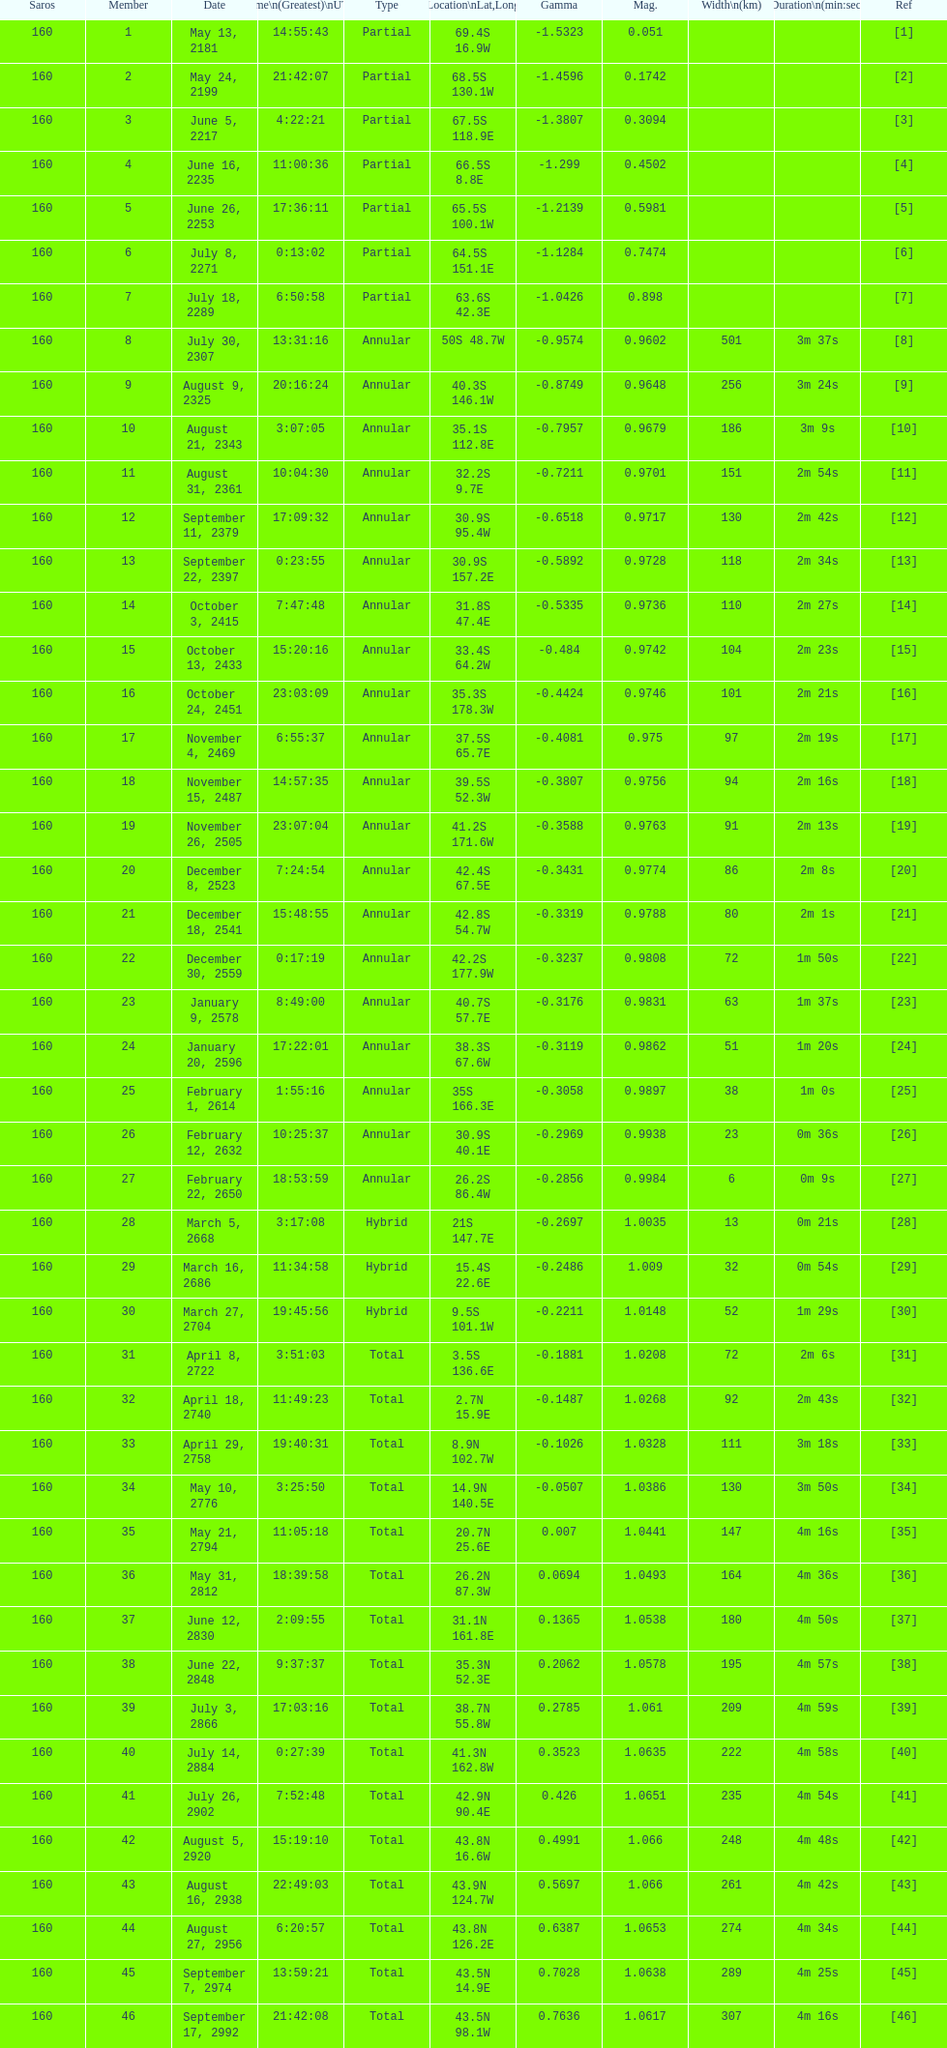When did the initial solar saros with a magnitude surpassing March 5, 2668. 